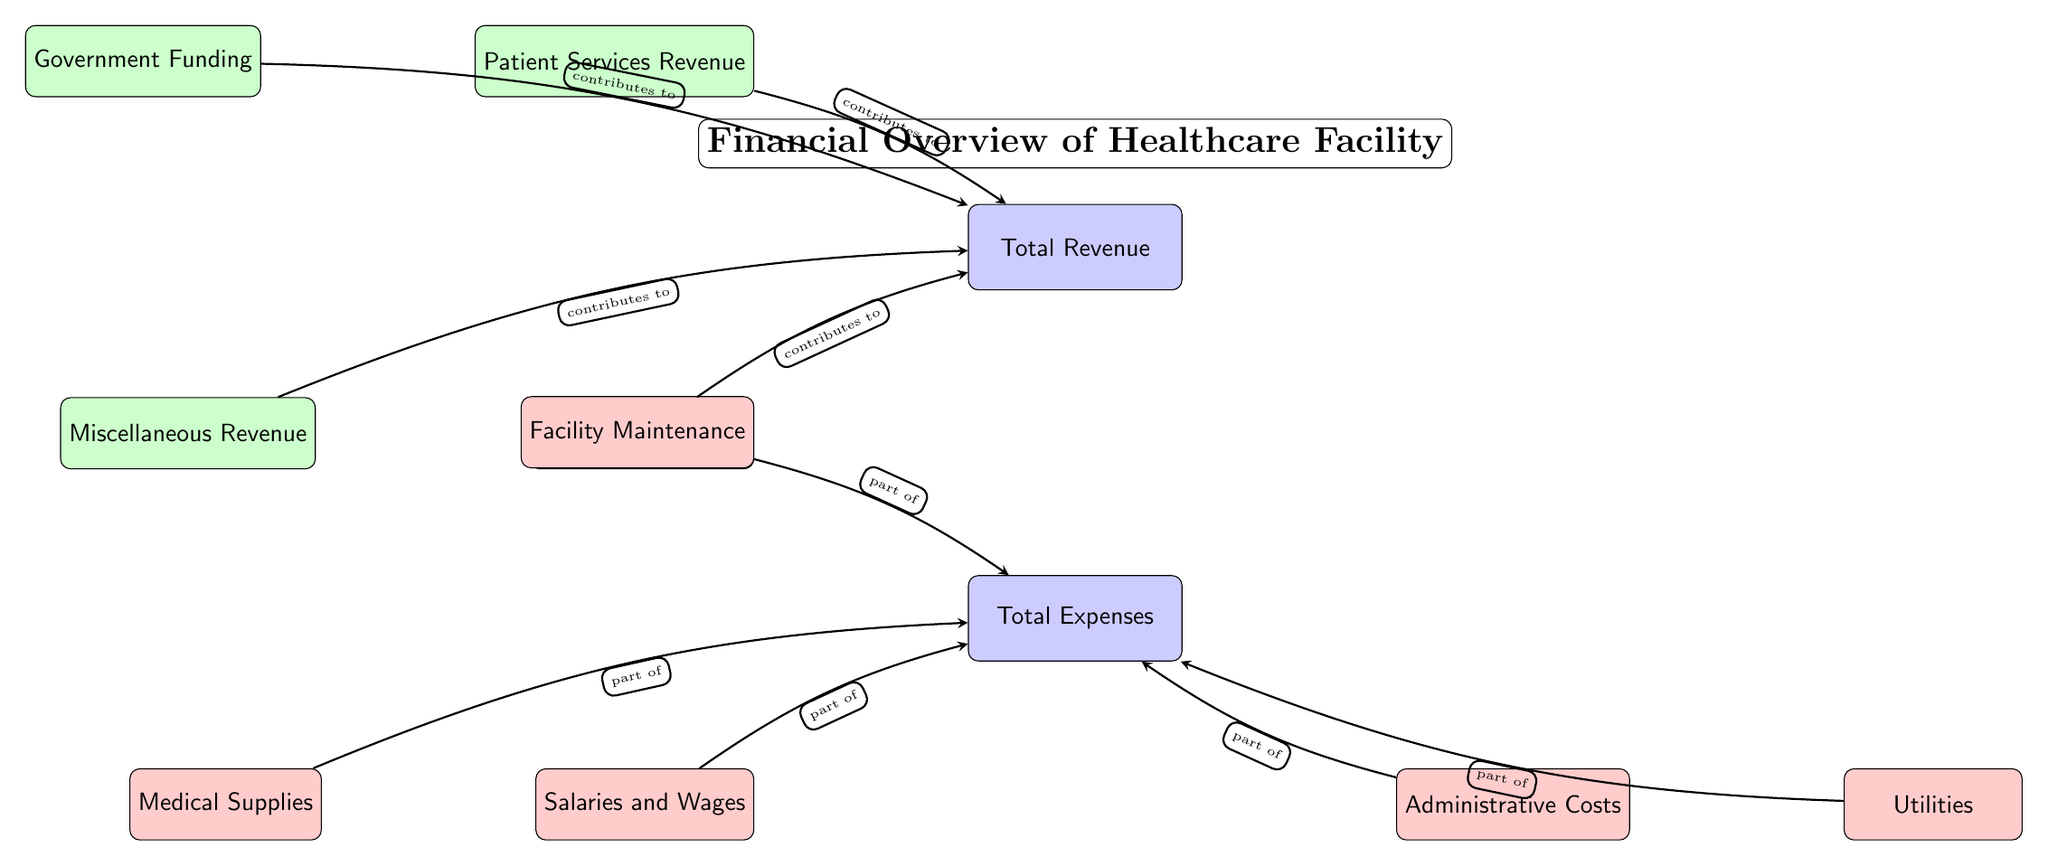What are the revenue streams listed in the diagram? The diagram shows four specific revenue streams contributing to total revenue: Patient Services Revenue, Government Funding, Insurance Payments, and Miscellaneous Revenue.
Answer: Patient Services Revenue, Government Funding, Insurance Payments, Miscellaneous Revenue What is the total category at the top of the diagram? The diagram provides two primary categories: Total Revenue and Total Expenses. The top node is labeled as Total Revenue.
Answer: Total Revenue How many expense categories are identified in the diagram? The diagram lists five expense categories that contribute to Total Expenses: Salaries and Wages, Medical Supplies, Facility Maintenance, Administrative Costs, and Utilities. Counting these gives the total.
Answer: 5 Which category includes Salaries and Wages? According to the diagram, Salaries and Wages is categorized under Total Expenses since it contributes to that part of the financial overview.
Answer: Total Expenses How do the Insurance Payments relate to Total Revenue? The diagram indicates that Insurance Payments contribute to Total Revenue, connecting Insurance Payments node with an arrow directed towards the Total Revenue node, signifying their role in the overall income.
Answer: contributes to What are the expenses associated with maintaining the facility? From the diagram, the specific expense associated with maintaining the facility is labeled as Facility Maintenance, which is part of the total expenses.
Answer: Facility Maintenance Which revenue stream is positioned above the Total Revenue node? The diagram places Patient Services Revenue directly above the Total Revenue node, indicating its positioning in the financial overview.
Answer: Patient Services Revenue What are the financial categories indicated by the color red in the diagram? The red color is used for expense categories in the diagram. Five expense categories: Salaries and Wages, Medical Supplies, Facility Maintenance, Administrative Costs, and Utilities are represented in red.
Answer: Salaries and Wages, Medical Supplies, Facility Maintenance, Administrative Costs, Utilities What does the arrow between Insurance Payments and Total Revenue signify? The arrow indicates that Insurance Payments are a contributing source of income, emphasizing their role in generating revenue for the healthcare facility as shown in the diagram.
Answer: contributes to 